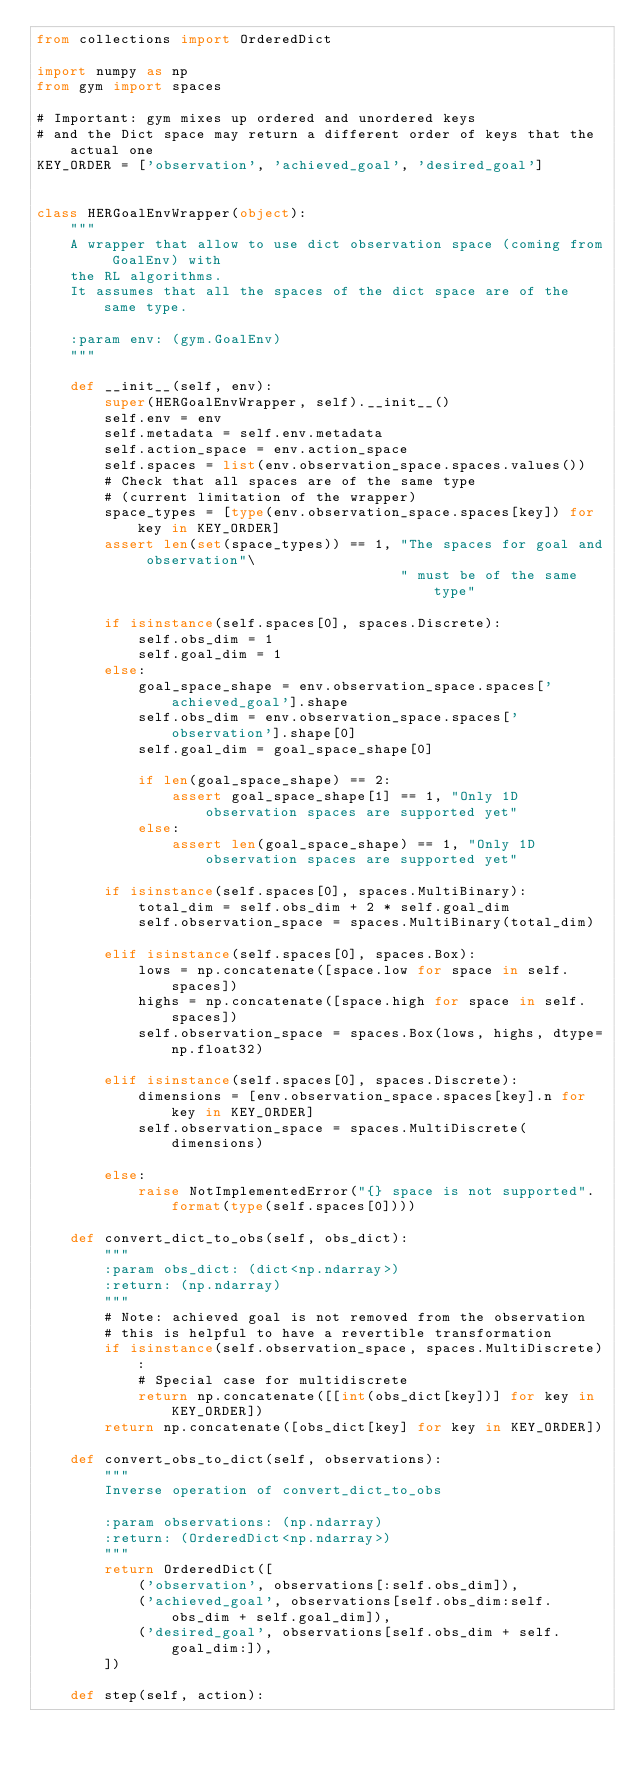Convert code to text. <code><loc_0><loc_0><loc_500><loc_500><_Python_>from collections import OrderedDict

import numpy as np
from gym import spaces

# Important: gym mixes up ordered and unordered keys
# and the Dict space may return a different order of keys that the actual one
KEY_ORDER = ['observation', 'achieved_goal', 'desired_goal']


class HERGoalEnvWrapper(object):
    """
    A wrapper that allow to use dict observation space (coming from GoalEnv) with
    the RL algorithms.
    It assumes that all the spaces of the dict space are of the same type.

    :param env: (gym.GoalEnv)
    """

    def __init__(self, env):
        super(HERGoalEnvWrapper, self).__init__()
        self.env = env
        self.metadata = self.env.metadata
        self.action_space = env.action_space
        self.spaces = list(env.observation_space.spaces.values())
        # Check that all spaces are of the same type
        # (current limitation of the wrapper)
        space_types = [type(env.observation_space.spaces[key]) for key in KEY_ORDER]
        assert len(set(space_types)) == 1, "The spaces for goal and observation"\
                                           " must be of the same type"

        if isinstance(self.spaces[0], spaces.Discrete):
            self.obs_dim = 1
            self.goal_dim = 1
        else:
            goal_space_shape = env.observation_space.spaces['achieved_goal'].shape
            self.obs_dim = env.observation_space.spaces['observation'].shape[0]
            self.goal_dim = goal_space_shape[0]

            if len(goal_space_shape) == 2:
                assert goal_space_shape[1] == 1, "Only 1D observation spaces are supported yet"
            else:
                assert len(goal_space_shape) == 1, "Only 1D observation spaces are supported yet"

        if isinstance(self.spaces[0], spaces.MultiBinary):
            total_dim = self.obs_dim + 2 * self.goal_dim
            self.observation_space = spaces.MultiBinary(total_dim)

        elif isinstance(self.spaces[0], spaces.Box):
            lows = np.concatenate([space.low for space in self.spaces])
            highs = np.concatenate([space.high for space in self.spaces])
            self.observation_space = spaces.Box(lows, highs, dtype=np.float32)

        elif isinstance(self.spaces[0], spaces.Discrete):
            dimensions = [env.observation_space.spaces[key].n for key in KEY_ORDER]
            self.observation_space = spaces.MultiDiscrete(dimensions)

        else:
            raise NotImplementedError("{} space is not supported".format(type(self.spaces[0])))

    def convert_dict_to_obs(self, obs_dict):
        """
        :param obs_dict: (dict<np.ndarray>)
        :return: (np.ndarray)
        """
        # Note: achieved goal is not removed from the observation
        # this is helpful to have a revertible transformation
        if isinstance(self.observation_space, spaces.MultiDiscrete):
            # Special case for multidiscrete
            return np.concatenate([[int(obs_dict[key])] for key in KEY_ORDER])
        return np.concatenate([obs_dict[key] for key in KEY_ORDER])

    def convert_obs_to_dict(self, observations):
        """
        Inverse operation of convert_dict_to_obs

        :param observations: (np.ndarray)
        :return: (OrderedDict<np.ndarray>)
        """
        return OrderedDict([
            ('observation', observations[:self.obs_dim]),
            ('achieved_goal', observations[self.obs_dim:self.obs_dim + self.goal_dim]),
            ('desired_goal', observations[self.obs_dim + self.goal_dim:]),
        ])

    def step(self, action):</code> 